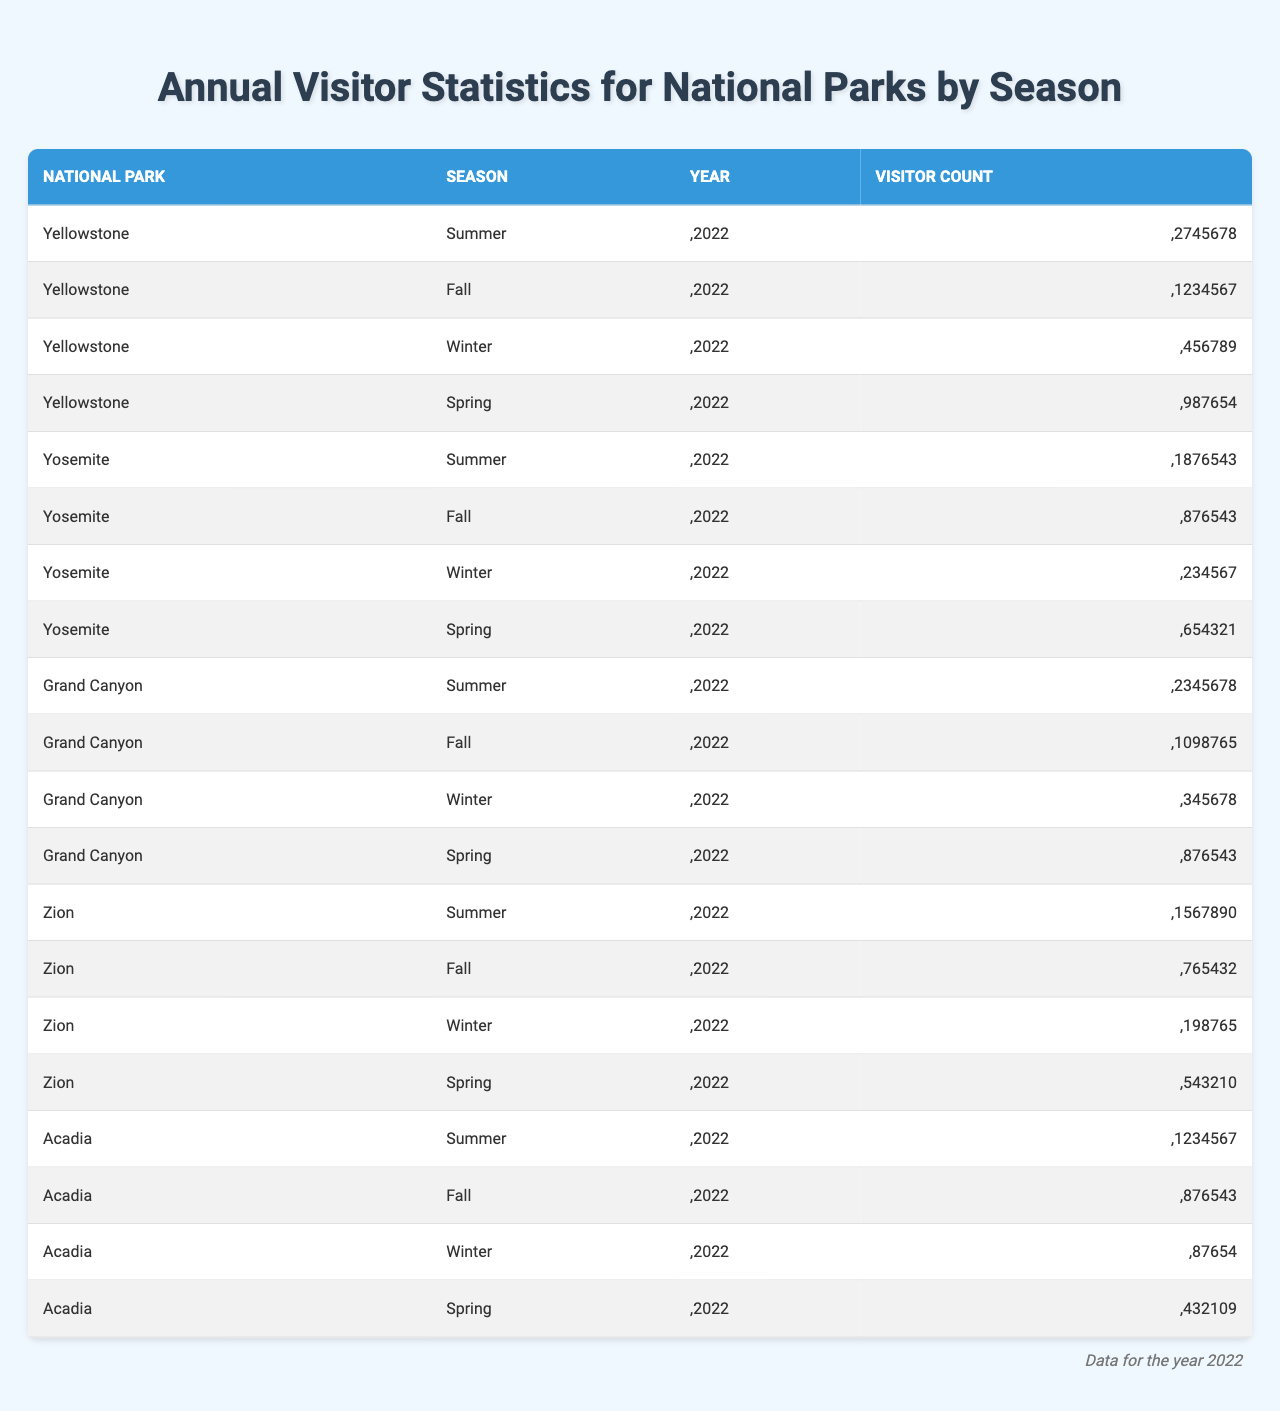What is the total visitor count for Yellowstone in 2022? To find the total visitor count for Yellowstone, we sum the visitor counts across all seasons: Summer (2,745,678) + Fall (1,234,567) + Winter (456,789) + Spring (987,654) = 5,424,688.
Answer: 5,424,688 Which season had the highest visitor count in Yosemite during 2022? Looking at the visitor counts for each season in Yosemite: Summer (1,876,543), Fall (876,543), Winter (234,567), Spring (654,321), Summer had the highest count.
Answer: Summer What was the overall visitor count for Grand Canyon in Fall 2022? The visitor count for Grand Canyon in Fall 2022 is explicitly listed in the table as 1,098,765.
Answer: 1,098,765 Was the visitor count for Zion in Spring 2022 higher or lower than the visitor count in Winter? The visitor count for Zion in Spring 2022 was 543,210 while in Winter it was 198,765. Since 543,210 is greater than 198,765, the count was higher in Spring.
Answer: Higher What is the average visitor count for all seasons across all parks for the year 2022? To compute the average visitor count, first sum all counts: 2,745,678 + 1,234,567 + 456,789 + 987,654 + 1,876,543 + 876,543 + 234,567 + 654,321 + 2,345,678 + 1,098,765 + 345,678 + 876,543 + 1,567,890 + 765,432 + 198,765 + 543,210 + 1,234,567 + 876,543 + 87,654 + 432,109 = 16,787,425, then divide by the total number of entries (20) to find the average: 16,787,425 / 20 = 839,371.25.
Answer: 839,371.25 Which national park had the lowest total visitor count in Winter across all parks? The visitor counts for Winter are: Yellowstone (456,789), Yosemite (234,567), Grand Canyon (345,678), and Zion (198,765). The lowest among these is Zion with 198,765.
Answer: Zion How many more visitors did Acadia receive in Fall compared to Spring in 2022? The visitor count for Acadia in Fall was 876,543 and in Spring was 432,109. To find the difference, subtract Spring from Fall: 876,543 - 432,109 = 444,434.
Answer: 444,434 What percentage of the total visitors for Yosemite in 2022 were there in Summer? First, find the total visitors for Yosemite: 1,876,543 (Summer) + 876,543 (Fall) + 234,567 (Winter) + 654,321 (Spring) = 3,642,974. The percentage for Summer is (1,876,543 / 3,642,974) * 100 = 51.5%.
Answer: 51.5% Which season had the lowest visitor count across all parks? The visitor counts for each season are: Summer (2,745,678 + 1,876,543 + 2,345,678 + 1,567,890 + 1,234,567), Fall (1,234,567 + 876,543 + 1,098,765 + 765,432 + 876,543), Winter (456,789 + 234,567 + 345,678 + 198,765 + 87,654), Spring (987,654 + 654,321 + 876,543 + 543,210 + 432,109). The total for Winter is the smallest at 1,323,451.
Answer: Winter Did any national park have a visitor count in Spring that exceeded 1 million in 2022? The visitor counts in Spring are: Yellowstone (987,654), Yosemite (654,321), Grand Canyon (876,543), Zion (543,210), and Acadia (432,109). None surpassed 1 million.
Answer: No 